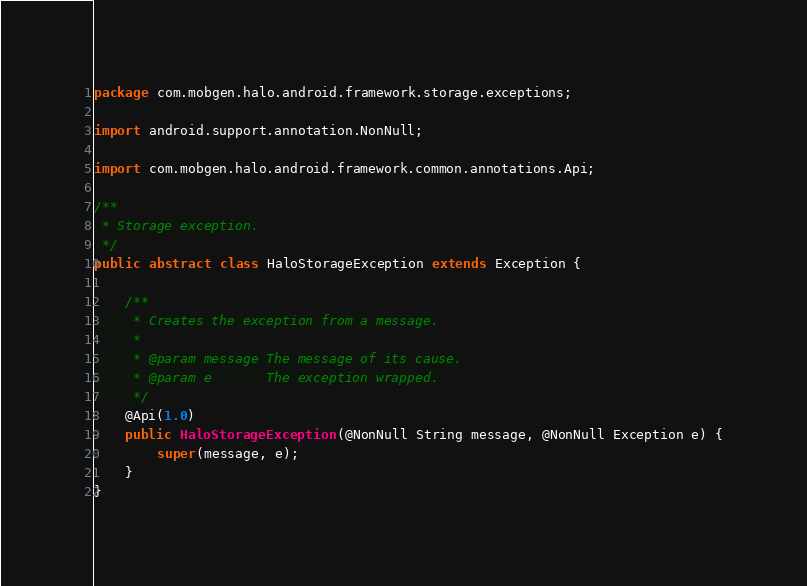Convert code to text. <code><loc_0><loc_0><loc_500><loc_500><_Java_>package com.mobgen.halo.android.framework.storage.exceptions;

import android.support.annotation.NonNull;

import com.mobgen.halo.android.framework.common.annotations.Api;

/**
 * Storage exception.
 */
public abstract class HaloStorageException extends Exception {

    /**
     * Creates the exception from a message.
     *
     * @param message The message of its cause.
     * @param e       The exception wrapped.
     */
    @Api(1.0)
    public HaloStorageException(@NonNull String message, @NonNull Exception e) {
        super(message, e);
    }
}
</code> 